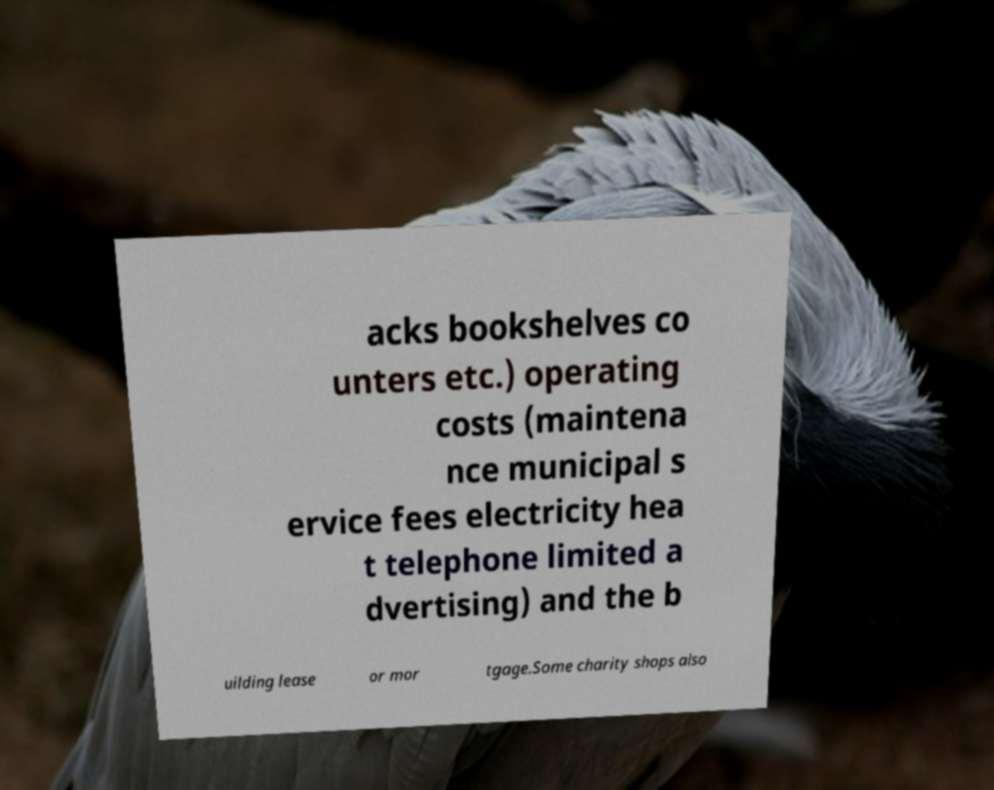Could you assist in decoding the text presented in this image and type it out clearly? acks bookshelves co unters etc.) operating costs (maintena nce municipal s ervice fees electricity hea t telephone limited a dvertising) and the b uilding lease or mor tgage.Some charity shops also 